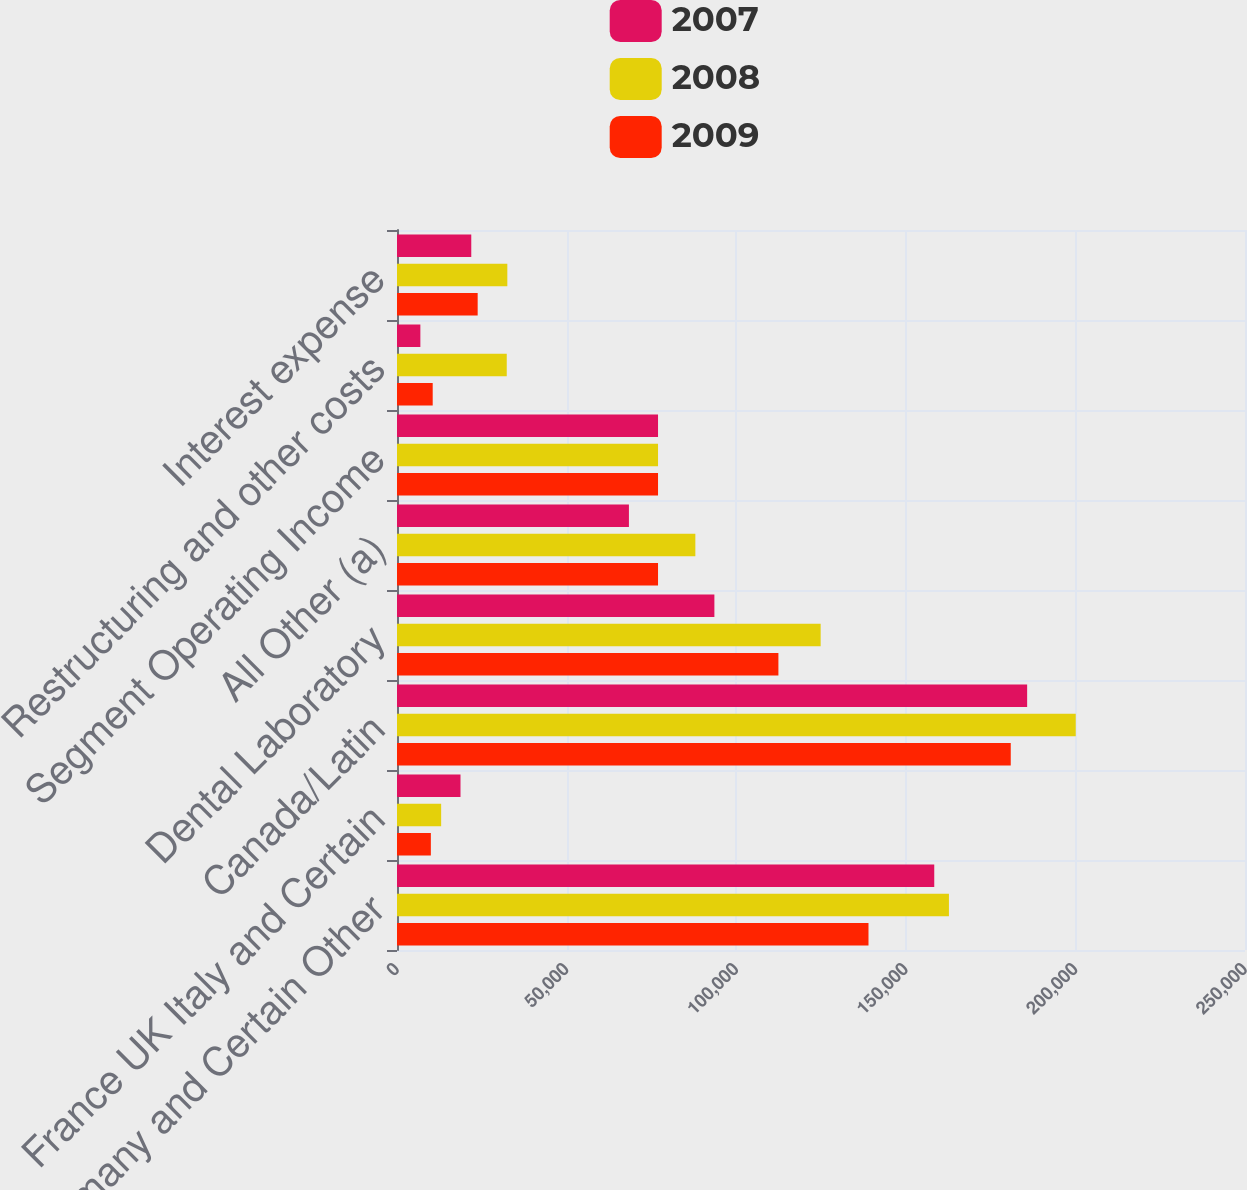Convert chart to OTSL. <chart><loc_0><loc_0><loc_500><loc_500><stacked_bar_chart><ecel><fcel>US Germany and Certain Other<fcel>France UK Italy and Certain<fcel>Canada/Latin<fcel>Dental Laboratory<fcel>All Other (a)<fcel>Segment Operating Income<fcel>Restructuring and other costs<fcel>Interest expense<nl><fcel>2007<fcel>158389<fcel>18721<fcel>185772<fcel>93569<fcel>68374<fcel>76954<fcel>6890<fcel>21896<nl><fcel>2008<fcel>162717<fcel>13017<fcel>200101<fcel>124898<fcel>87957<fcel>76954<fcel>32355<fcel>32527<nl><fcel>2009<fcel>139001<fcel>9983<fcel>180944<fcel>112444<fcel>76954<fcel>76954<fcel>10527<fcel>23783<nl></chart> 